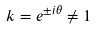<formula> <loc_0><loc_0><loc_500><loc_500>k = e ^ { \pm i \theta } \neq 1</formula> 